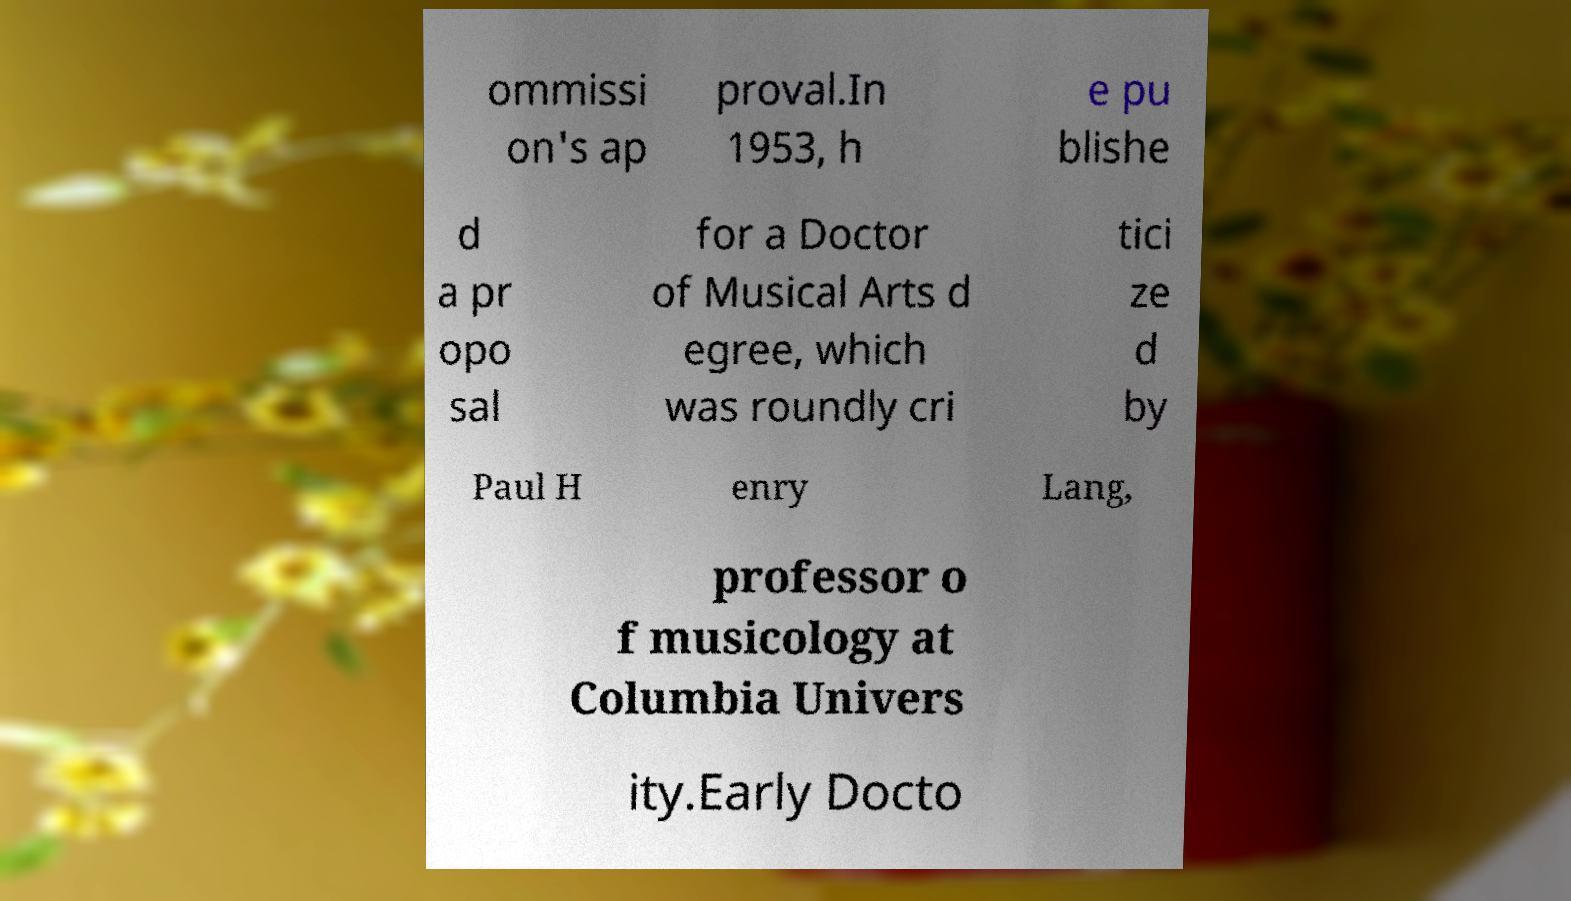Could you extract and type out the text from this image? ommissi on's ap proval.In 1953, h e pu blishe d a pr opo sal for a Doctor of Musical Arts d egree, which was roundly cri tici ze d by Paul H enry Lang, professor o f musicology at Columbia Univers ity.Early Docto 